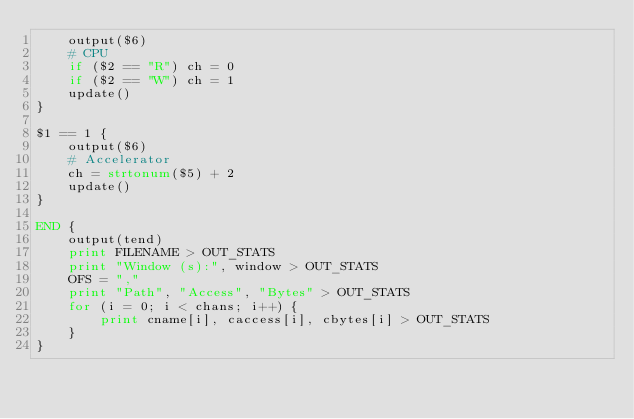Convert code to text. <code><loc_0><loc_0><loc_500><loc_500><_Awk_>	output($6)
	# CPU
	if ($2 == "R") ch = 0
	if ($2 == "W") ch = 1
	update()
}

$1 == 1 {
	output($6)
	# Accelerator
	ch = strtonum($5) + 2
	update()
}

END {
	output(tend)
	print FILENAME > OUT_STATS
	print "Window (s):", window > OUT_STATS
	OFS = ","
	print "Path", "Access", "Bytes" > OUT_STATS
	for (i = 0; i < chans; i++) {
		print cname[i], caccess[i], cbytes[i] > OUT_STATS
	}
}
</code> 